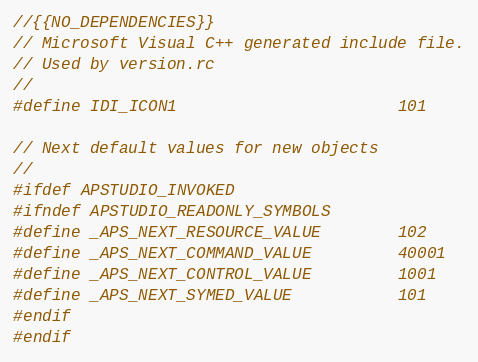<code> <loc_0><loc_0><loc_500><loc_500><_C_>//{{NO_DEPENDENCIES}}
// Microsoft Visual C++ generated include file.
// Used by version.rc
//
#define IDI_ICON1                       101

// Next default values for new objects
// 
#ifdef APSTUDIO_INVOKED
#ifndef APSTUDIO_READONLY_SYMBOLS
#define _APS_NEXT_RESOURCE_VALUE        102
#define _APS_NEXT_COMMAND_VALUE         40001
#define _APS_NEXT_CONTROL_VALUE         1001
#define _APS_NEXT_SYMED_VALUE           101
#endif
#endif
</code> 